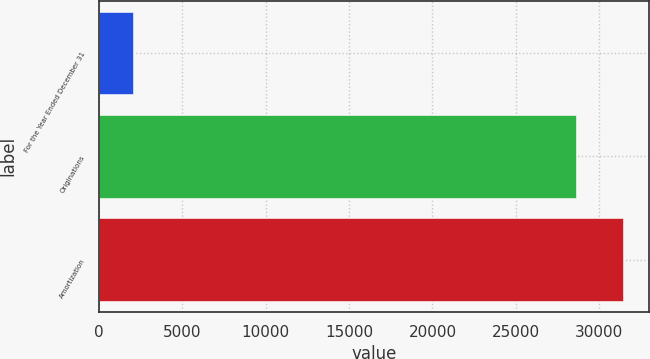Convert chart to OTSL. <chart><loc_0><loc_0><loc_500><loc_500><bar_chart><fcel>For the Year Ended December 31<fcel>Originations<fcel>Amortization<nl><fcel>2016<fcel>28618<fcel>31437.2<nl></chart> 